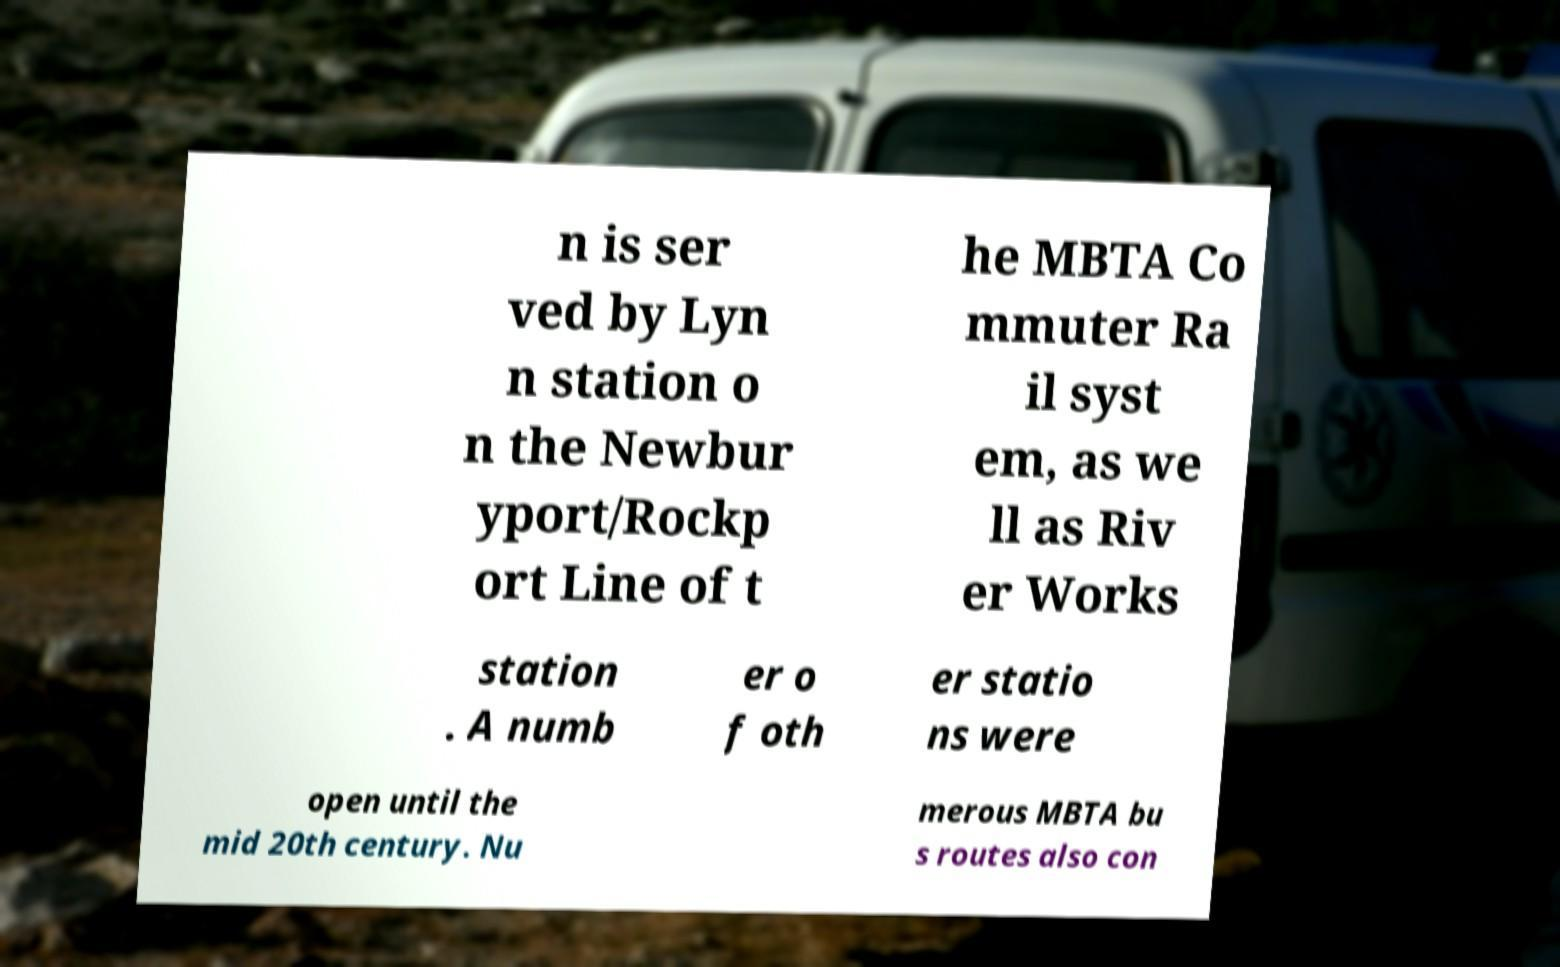Please read and relay the text visible in this image. What does it say? n is ser ved by Lyn n station o n the Newbur yport/Rockp ort Line of t he MBTA Co mmuter Ra il syst em, as we ll as Riv er Works station . A numb er o f oth er statio ns were open until the mid 20th century. Nu merous MBTA bu s routes also con 